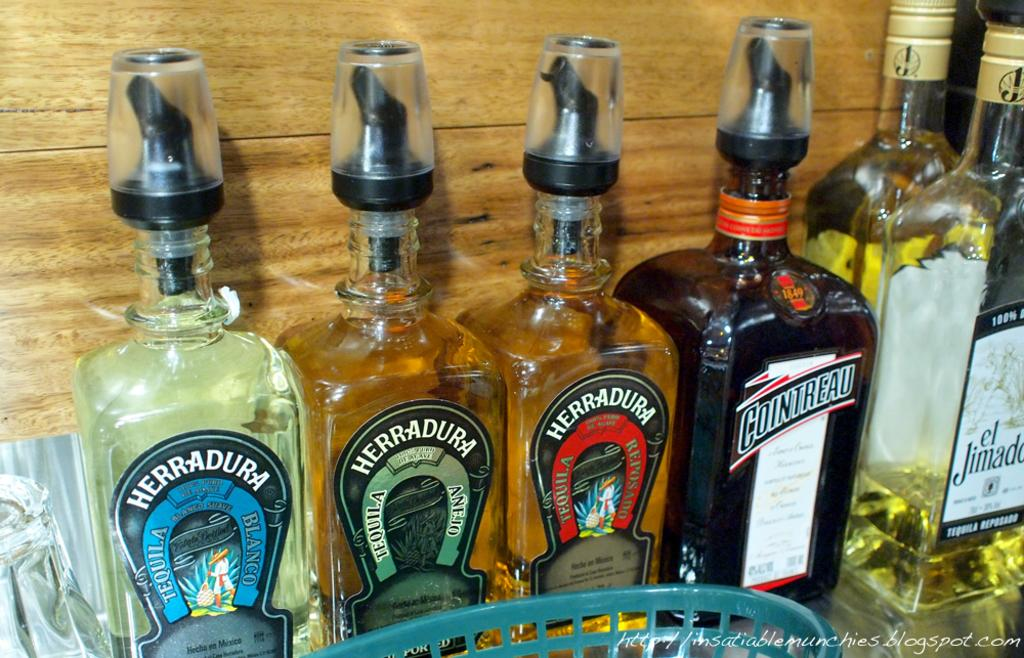<image>
Give a short and clear explanation of the subsequent image. Many colors of Herra-Dura alcohol next to a bottle of Cointreau. 